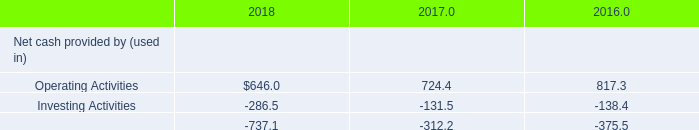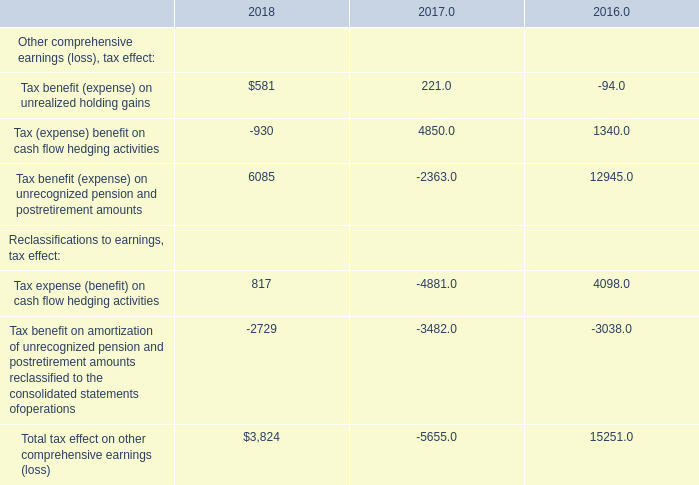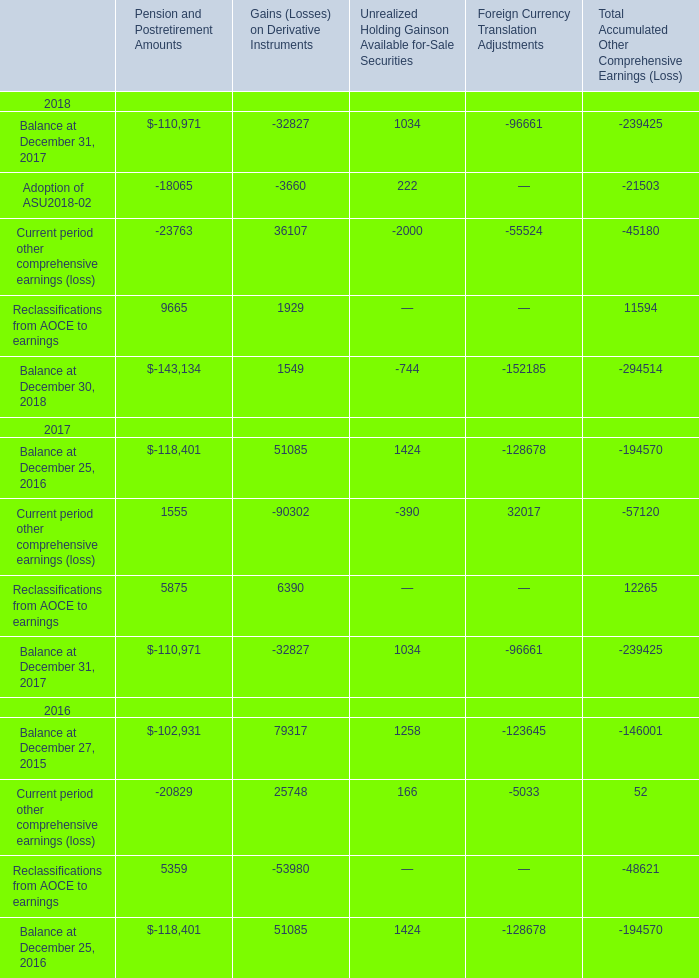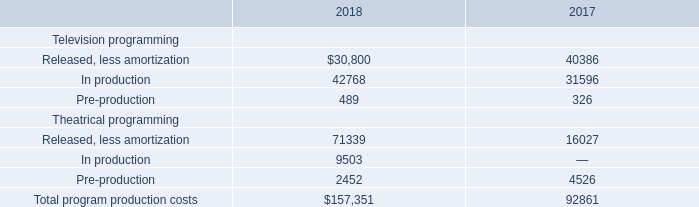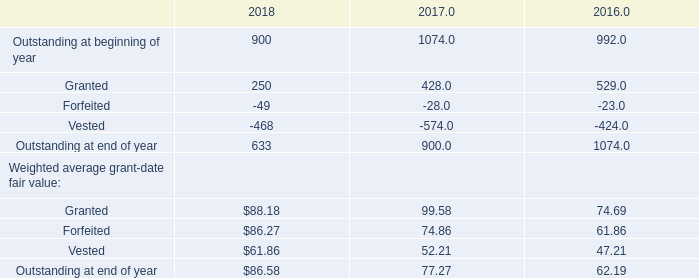Which year is Tax benefit (expense) on unrealized holding gains greater than 500? 
Answer: 2018. 